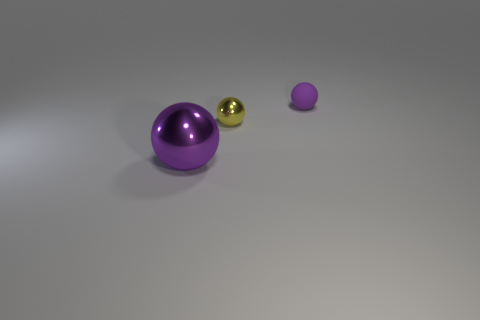Add 3 small blue shiny balls. How many objects exist? 6 Subtract all purple rubber balls. Subtract all rubber spheres. How many objects are left? 1 Add 2 tiny metallic things. How many tiny metallic things are left? 3 Add 1 green rubber cylinders. How many green rubber cylinders exist? 1 Subtract 0 red cylinders. How many objects are left? 3 